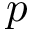Convert formula to latex. <formula><loc_0><loc_0><loc_500><loc_500>p</formula> 